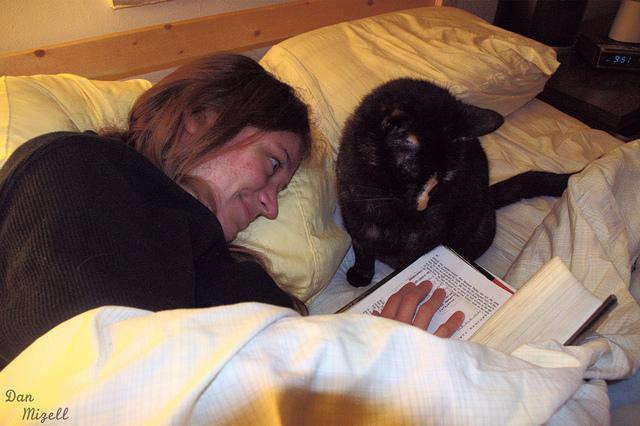How many food poles for the giraffes are there?
Give a very brief answer. 0. 